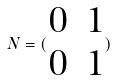Convert formula to latex. <formula><loc_0><loc_0><loc_500><loc_500>N = ( \begin{matrix} 0 & 1 \\ 0 & 1 \end{matrix} )</formula> 